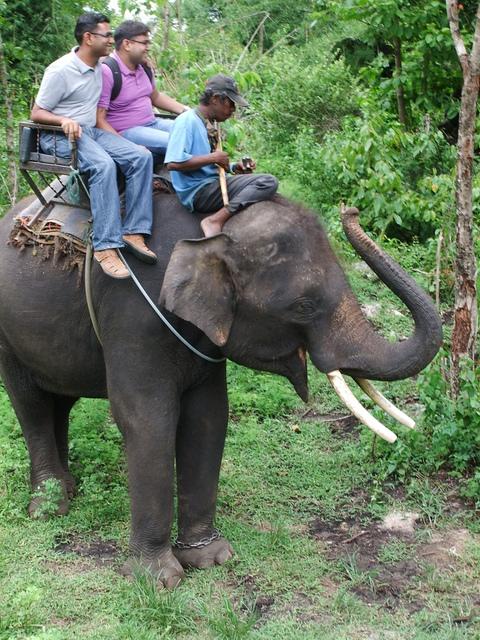Who is riding on the elephant?
Short answer required. Men. How many people are riding the elephant?
Give a very brief answer. 3. Is the elephant's trunk pointing upwards?
Quick response, please. Yes. Is the elephant being ridden on?
Be succinct. Yes. 